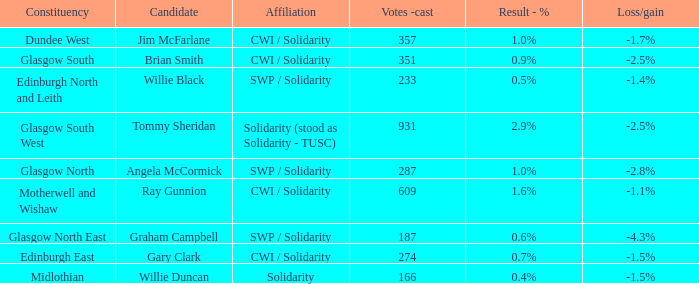4%? Willie Duncan. 